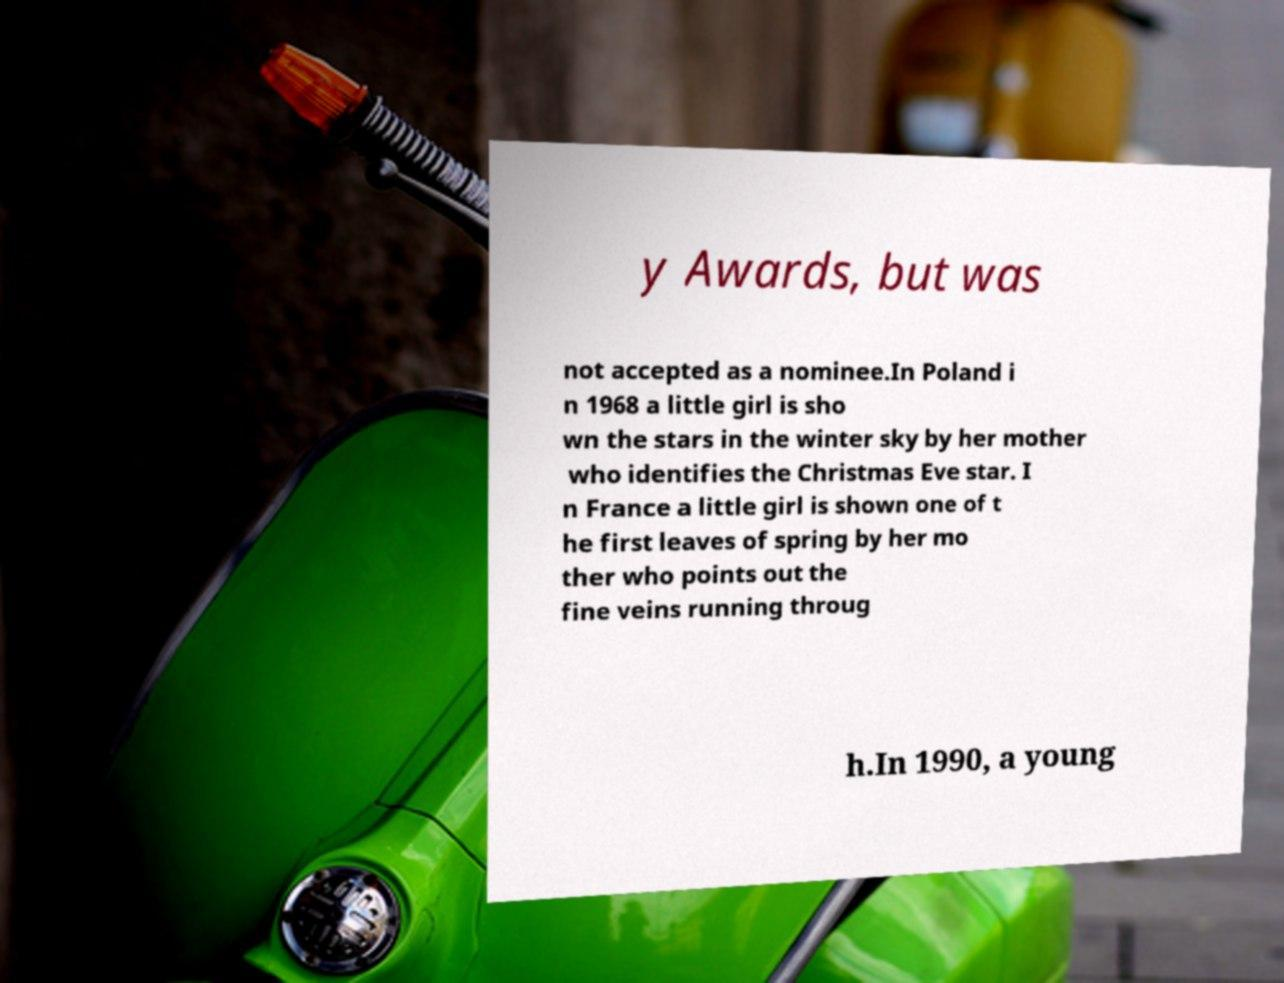Could you extract and type out the text from this image? y Awards, but was not accepted as a nominee.In Poland i n 1968 a little girl is sho wn the stars in the winter sky by her mother who identifies the Christmas Eve star. I n France a little girl is shown one of t he first leaves of spring by her mo ther who points out the fine veins running throug h.In 1990, a young 